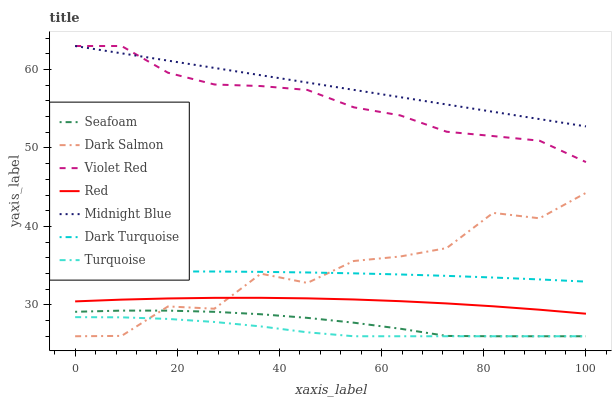Does Turquoise have the minimum area under the curve?
Answer yes or no. Yes. Does Midnight Blue have the maximum area under the curve?
Answer yes or no. Yes. Does Dark Turquoise have the minimum area under the curve?
Answer yes or no. No. Does Dark Turquoise have the maximum area under the curve?
Answer yes or no. No. Is Midnight Blue the smoothest?
Answer yes or no. Yes. Is Dark Salmon the roughest?
Answer yes or no. Yes. Is Dark Turquoise the smoothest?
Answer yes or no. No. Is Dark Turquoise the roughest?
Answer yes or no. No. Does Seafoam have the lowest value?
Answer yes or no. Yes. Does Dark Turquoise have the lowest value?
Answer yes or no. No. Does Midnight Blue have the highest value?
Answer yes or no. Yes. Does Dark Turquoise have the highest value?
Answer yes or no. No. Is Turquoise less than Violet Red?
Answer yes or no. Yes. Is Red greater than Turquoise?
Answer yes or no. Yes. Does Dark Salmon intersect Turquoise?
Answer yes or no. Yes. Is Dark Salmon less than Turquoise?
Answer yes or no. No. Is Dark Salmon greater than Turquoise?
Answer yes or no. No. Does Turquoise intersect Violet Red?
Answer yes or no. No. 